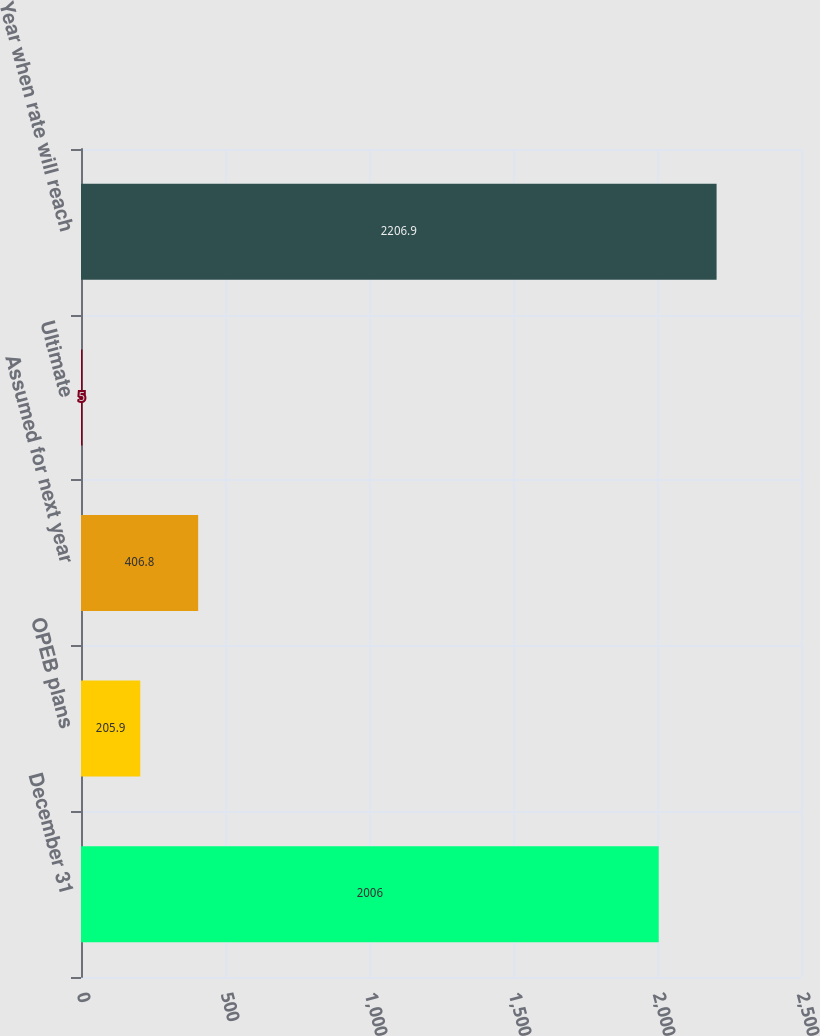Convert chart. <chart><loc_0><loc_0><loc_500><loc_500><bar_chart><fcel>December 31<fcel>OPEB plans<fcel>Assumed for next year<fcel>Ultimate<fcel>Year when rate will reach<nl><fcel>2006<fcel>205.9<fcel>406.8<fcel>5<fcel>2206.9<nl></chart> 